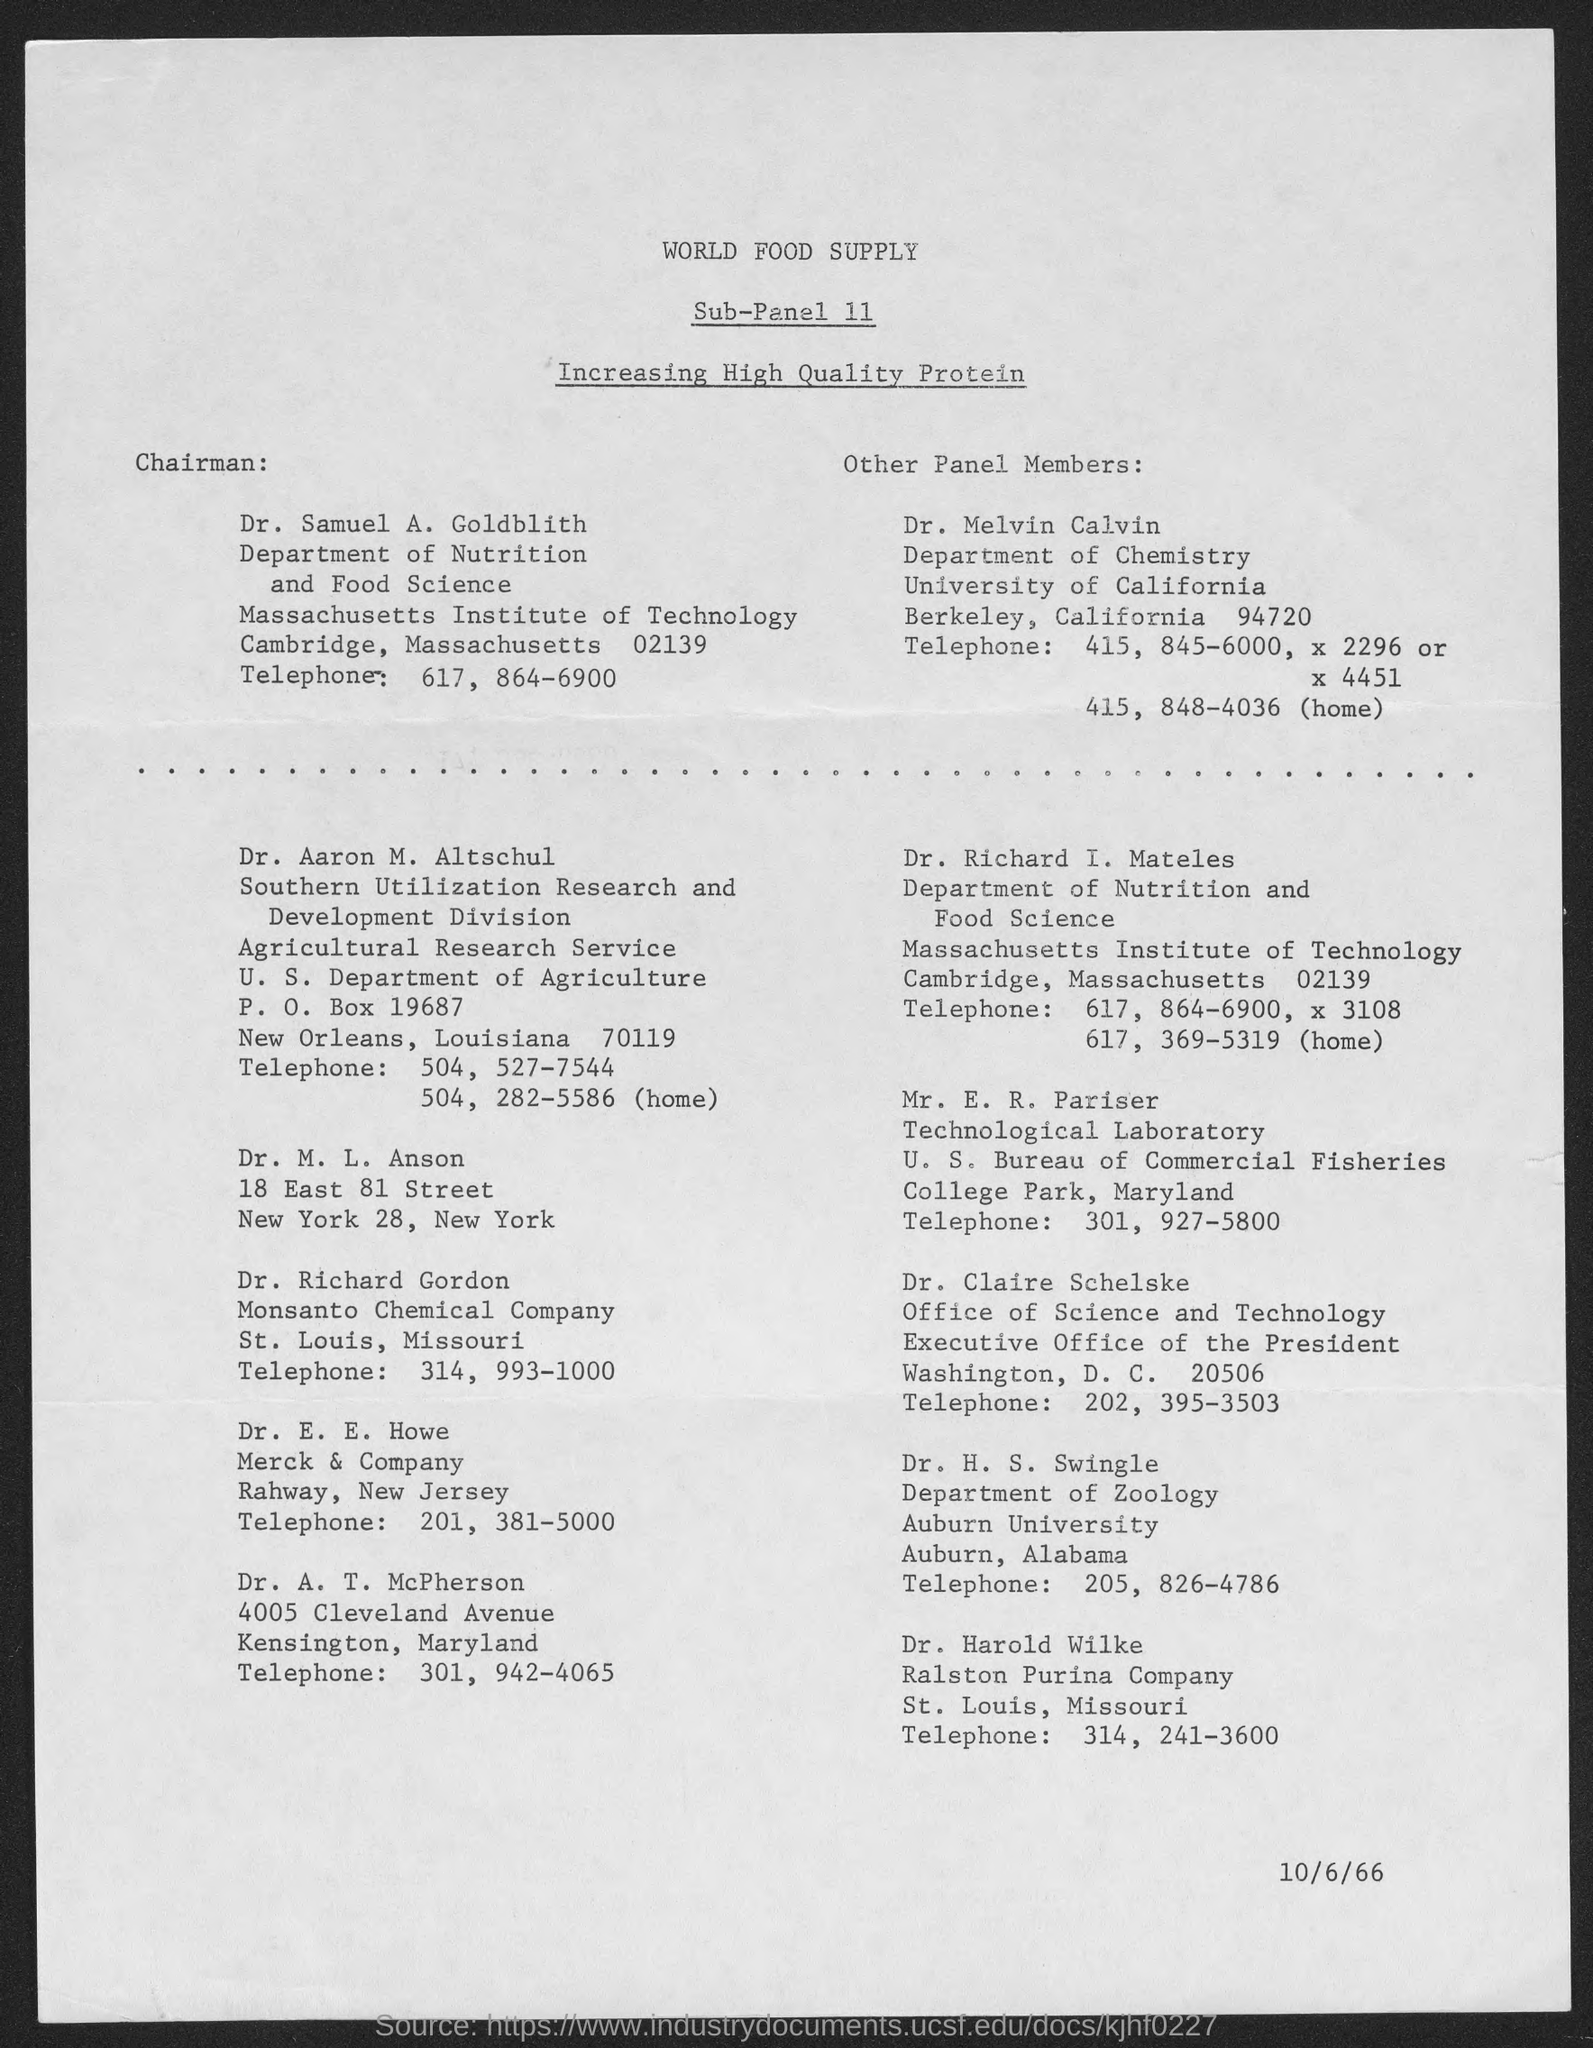What is the date?
Offer a very short reply. 10/6/66. Who is the chairman of  "Nutrition and Food Science"?
Give a very brief answer. Dr. Samuel A. Goldblith. What is the title of document?
Provide a succinct answer. World Food Supply. 